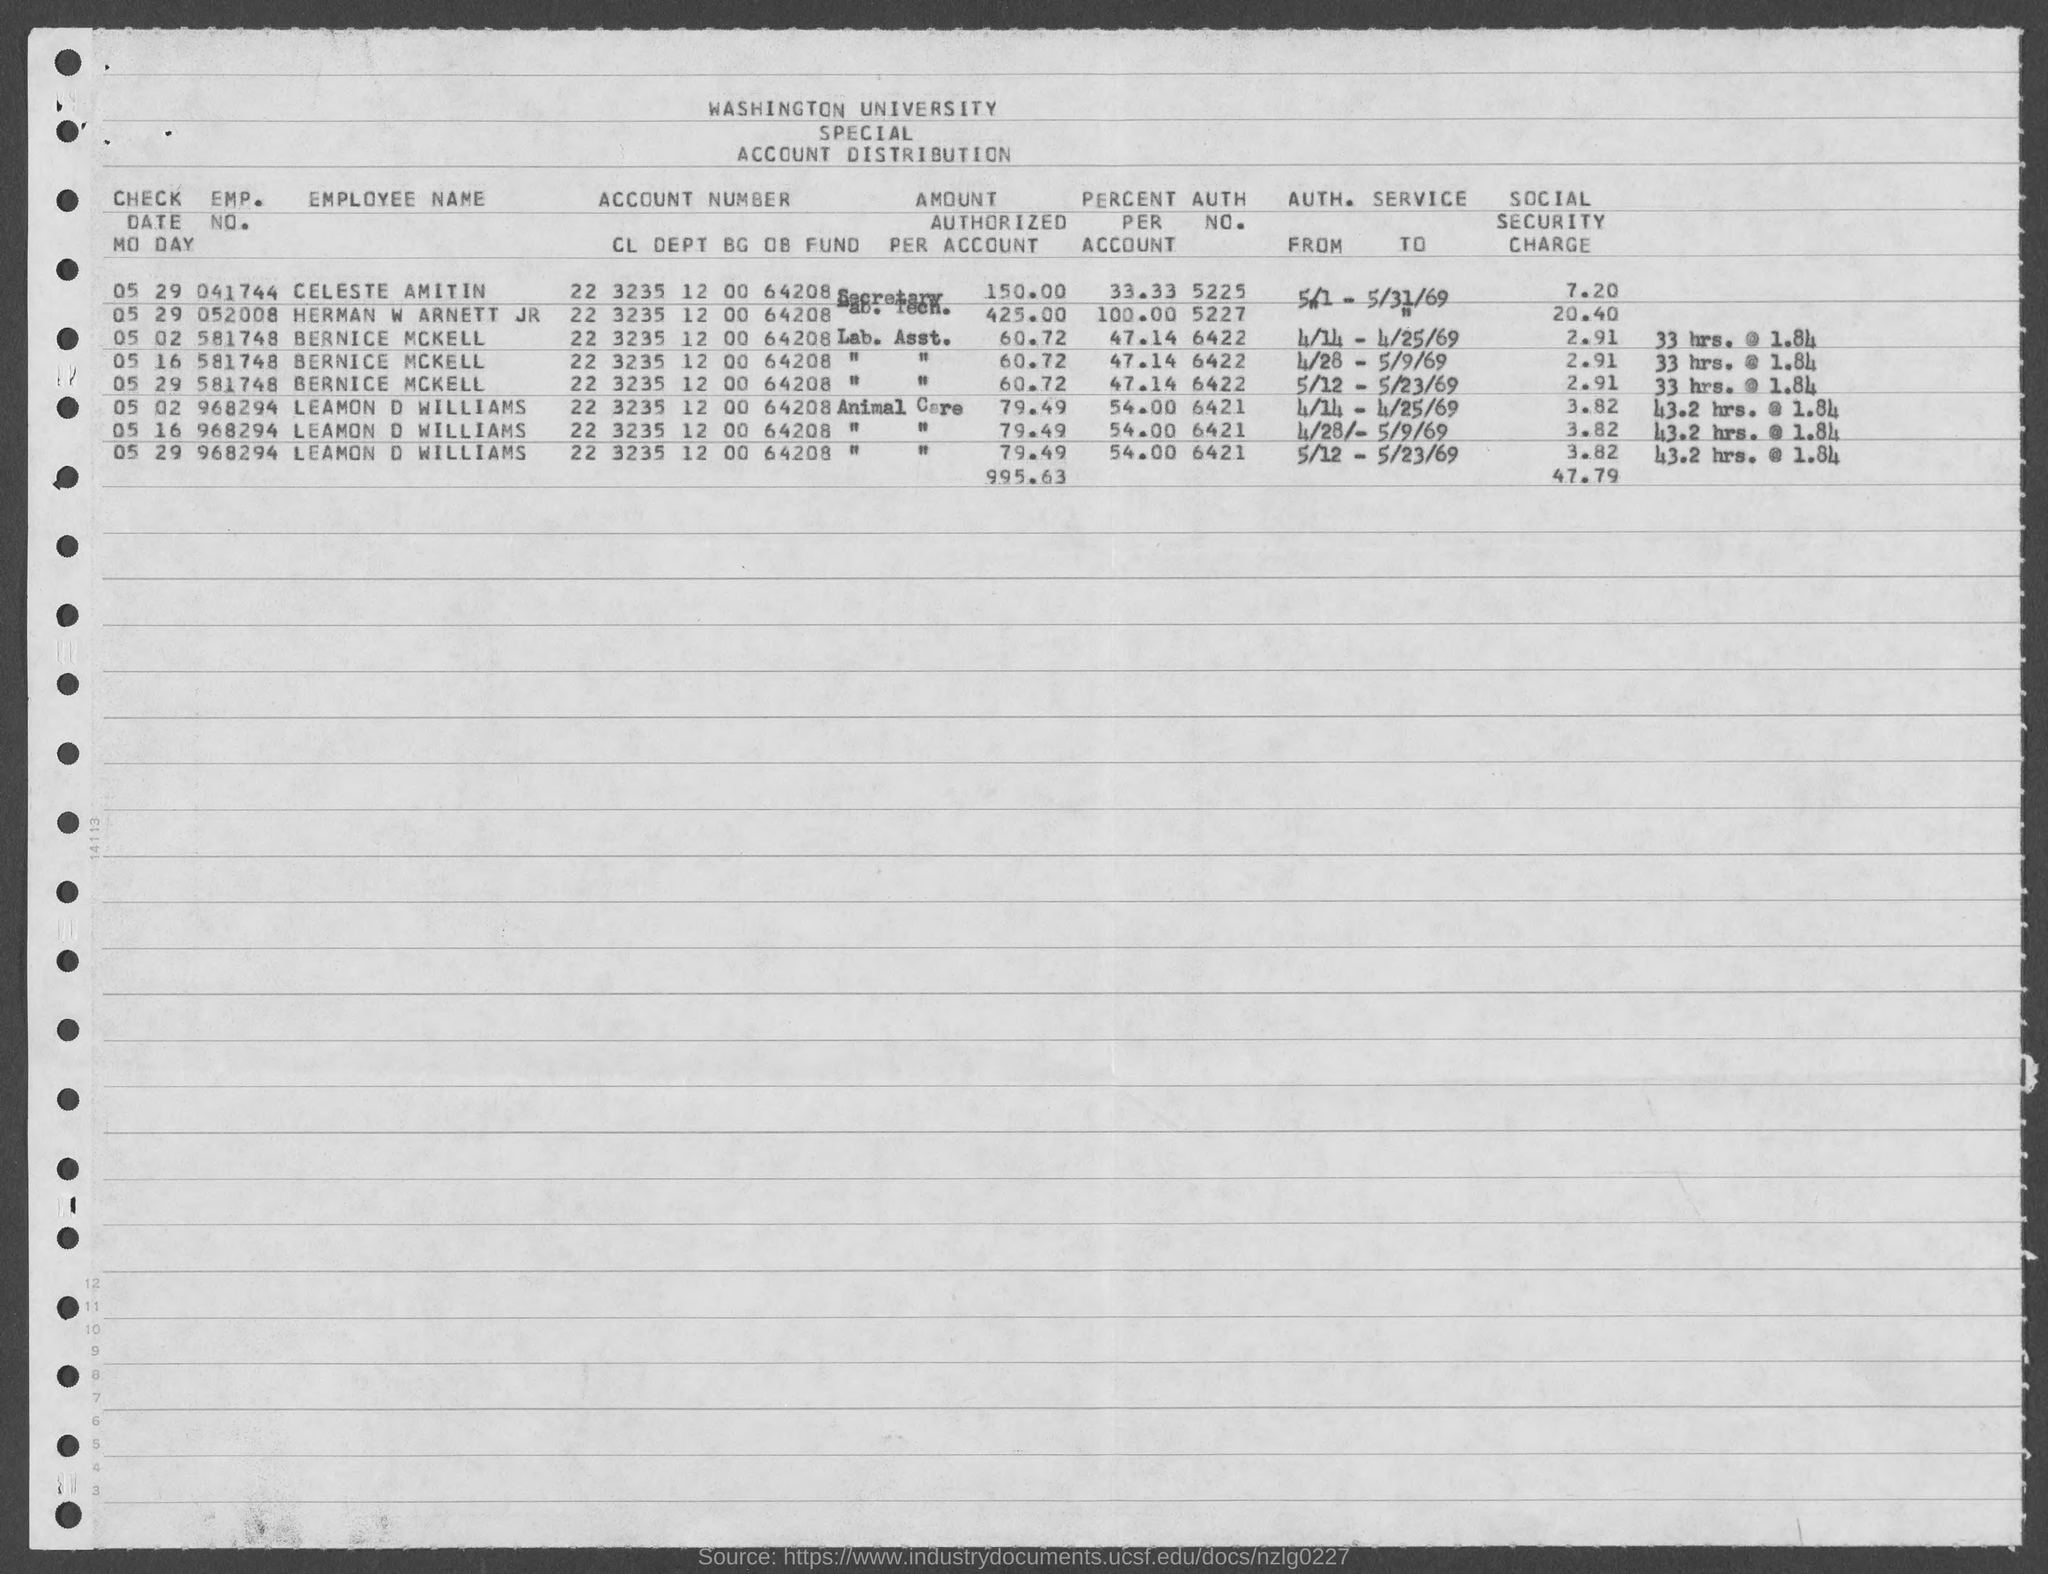What is the employee number of Celeste Amitin?
Offer a very short reply. 041744. What is the employee number of Bernice Mckell?
Give a very brief answer. 581748. What is the Account number of Celeste Amitin?
Give a very brief answer. 22 3235 12 00 64208. What is the Auth No. of  Bernice Mckell?
Make the answer very short. 6422. What is the social security charge for the Emp No. 052008?
Give a very brief answer. 20.40. What is the percent per account of Celeste Amitin?
Provide a short and direct response. 33.33. What is the amount authorized per account of Herman W Arnett JR?
Make the answer very short. 425.00. What is the Auth No. of Herman W Arnett JR?
Make the answer very short. 5227. 